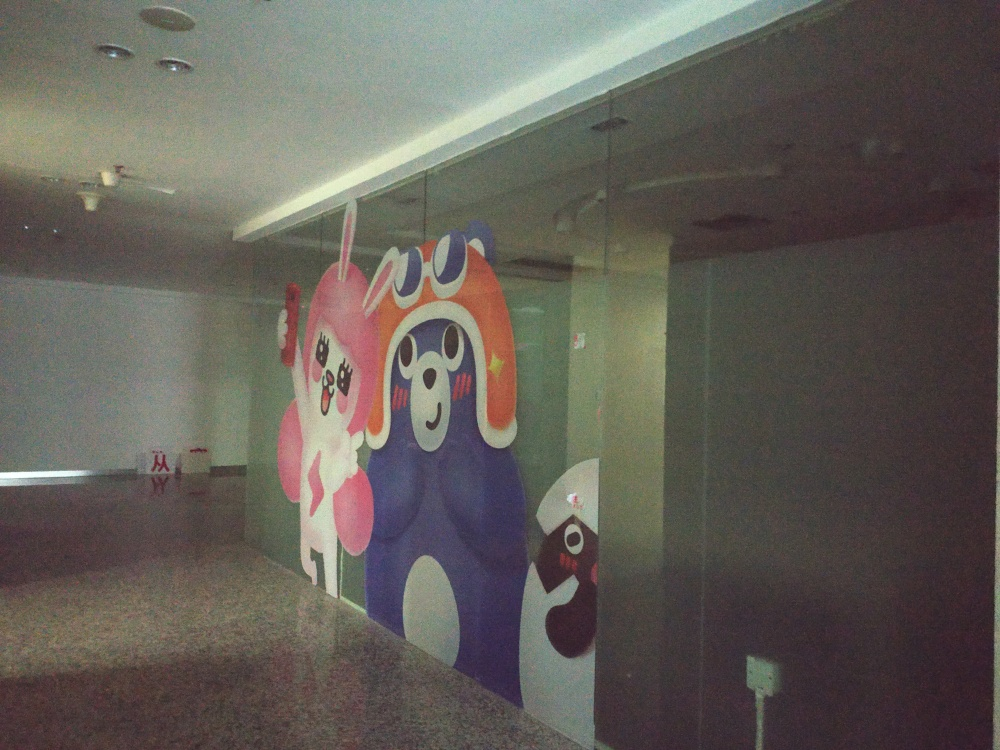Are there any cultural or social connotations associated with this type of mural? This type of mural, with its colorful and cartoonish characters, often has associations with contemporary pop culture and may be influenced by street art and graffiti traditions. It can reflect a community's desire for public art that is accessible, vibrant, and capable of brightening up urban spaces. Socially, such murals can signify a value placed on creativity, as well as a sense of playfulness and inclusivity within the culture that hosts them. 